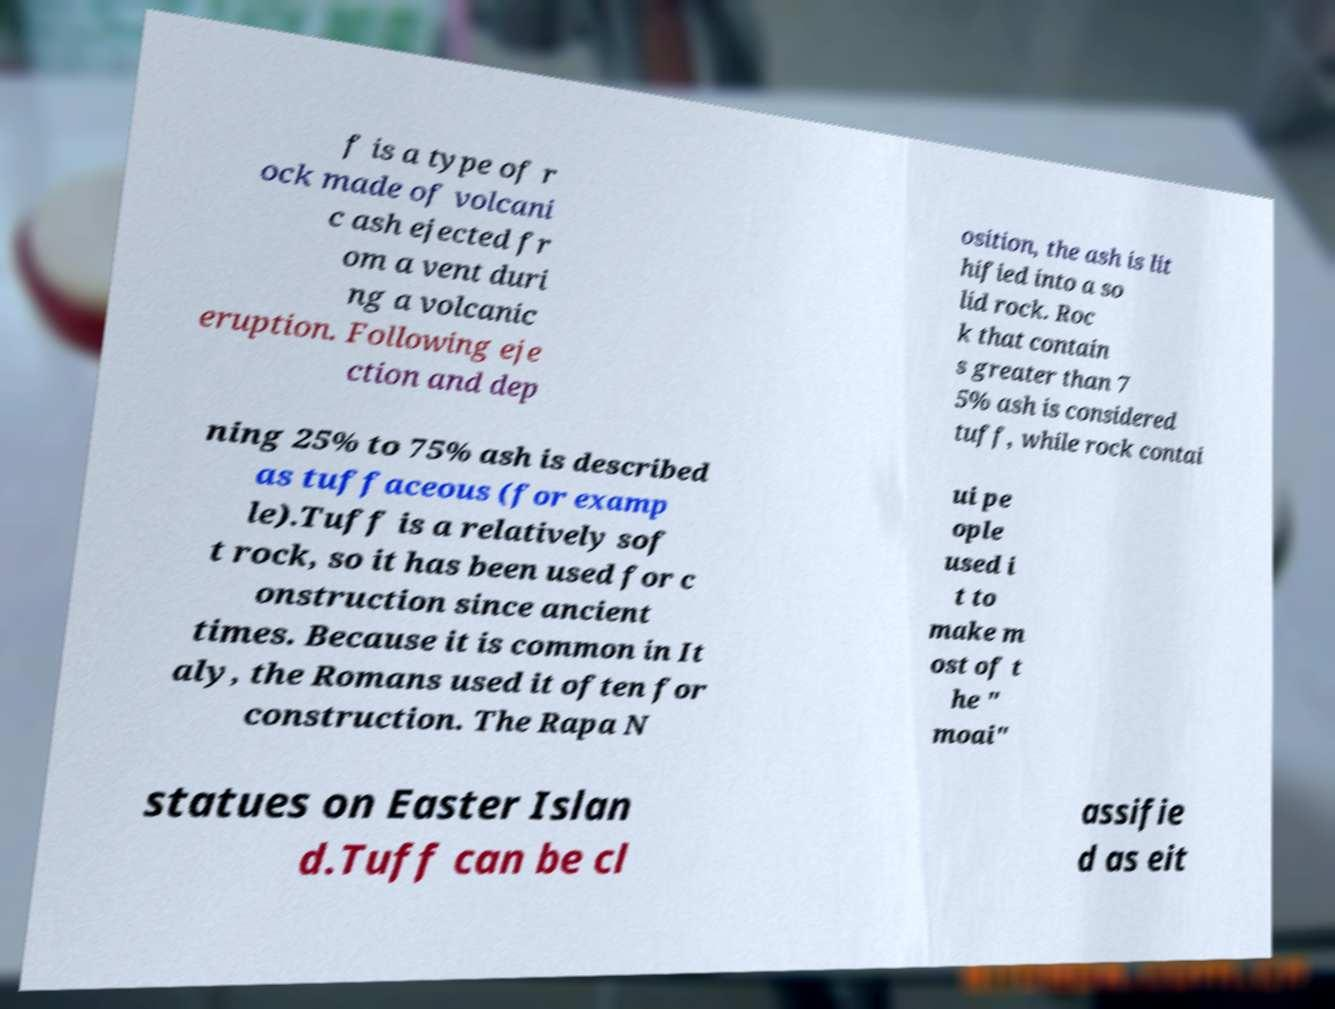Please identify and transcribe the text found in this image. f is a type of r ock made of volcani c ash ejected fr om a vent duri ng a volcanic eruption. Following eje ction and dep osition, the ash is lit hified into a so lid rock. Roc k that contain s greater than 7 5% ash is considered tuff, while rock contai ning 25% to 75% ash is described as tuffaceous (for examp le).Tuff is a relatively sof t rock, so it has been used for c onstruction since ancient times. Because it is common in It aly, the Romans used it often for construction. The Rapa N ui pe ople used i t to make m ost of t he " moai" statues on Easter Islan d.Tuff can be cl assifie d as eit 